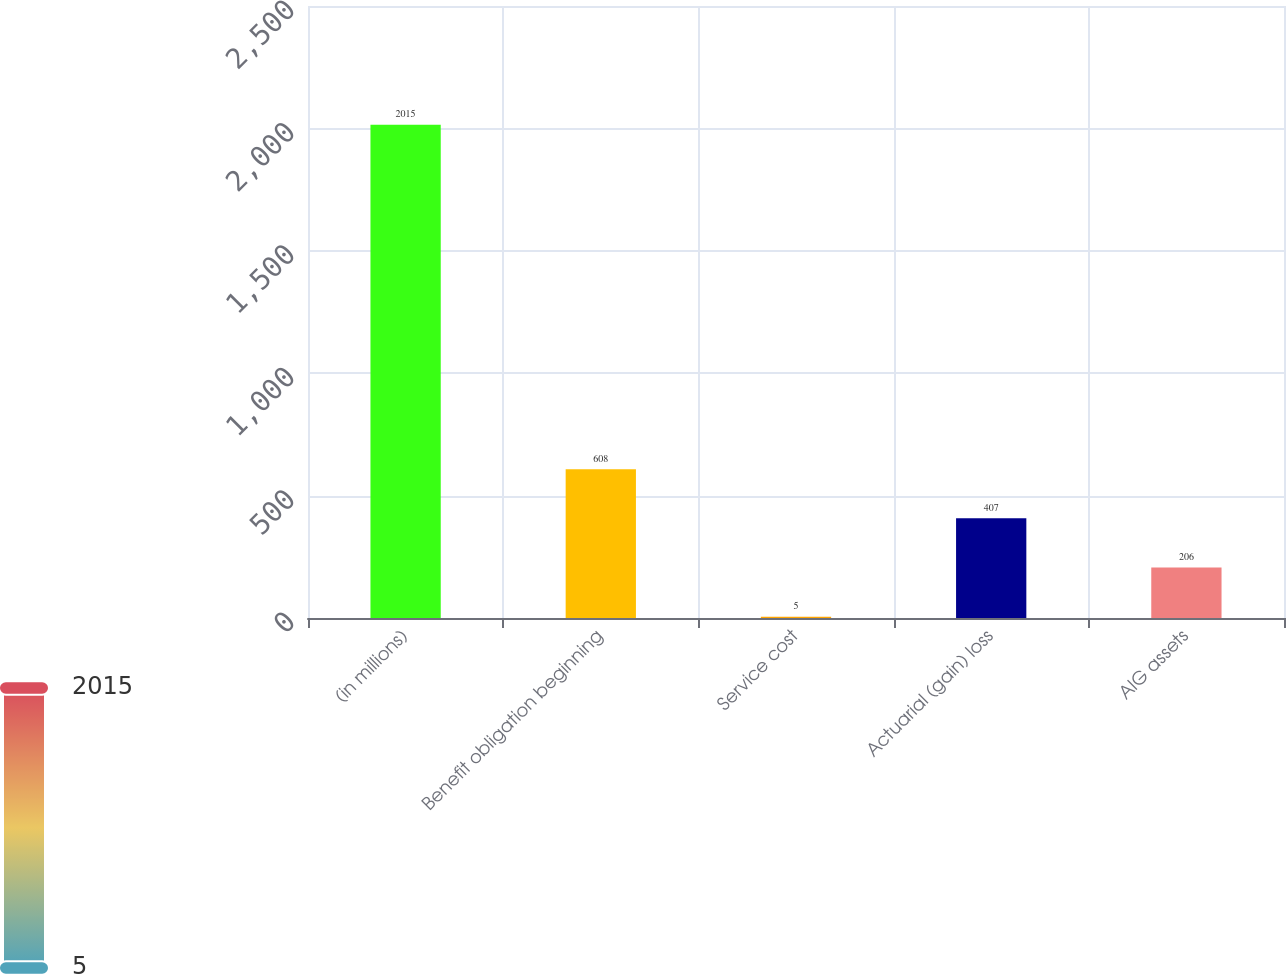<chart> <loc_0><loc_0><loc_500><loc_500><bar_chart><fcel>(in millions)<fcel>Benefit obligation beginning<fcel>Service cost<fcel>Actuarial (gain) loss<fcel>AIG assets<nl><fcel>2015<fcel>608<fcel>5<fcel>407<fcel>206<nl></chart> 